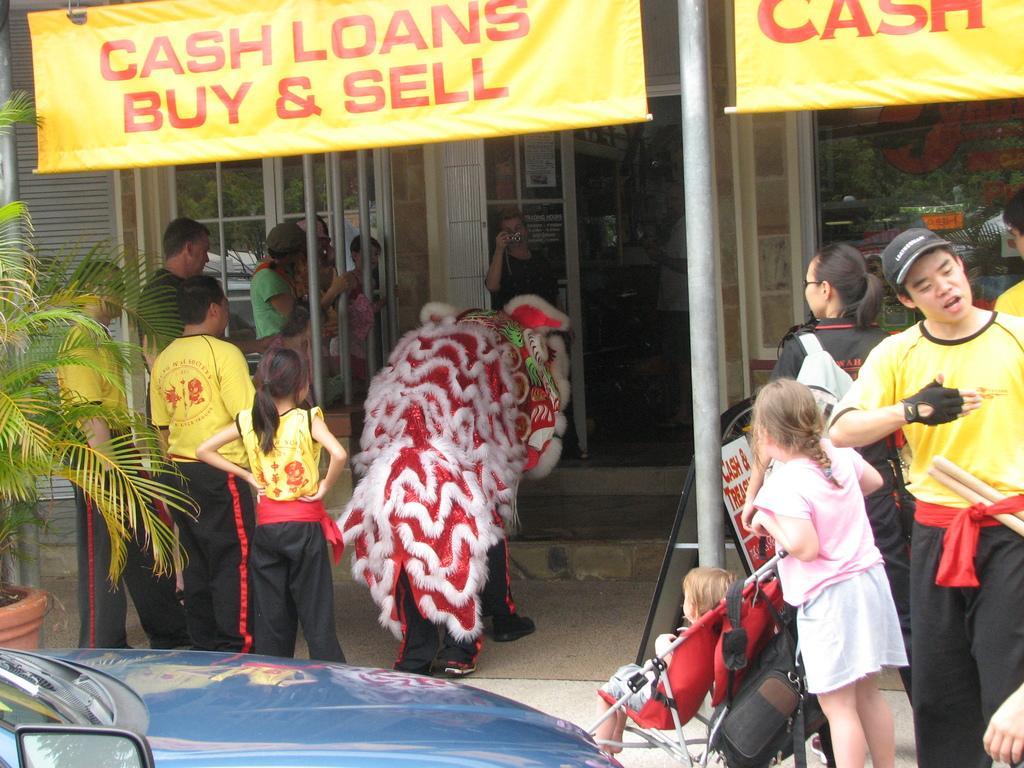In one or two sentences, can you explain what this image depicts? It looks like a store, on the left side 3 persons are there, they wore yellow color t-shirts and black color trousers. On the right side a girl is looking at that side, there is a banner in yellow color. On the left side there is a plant. 